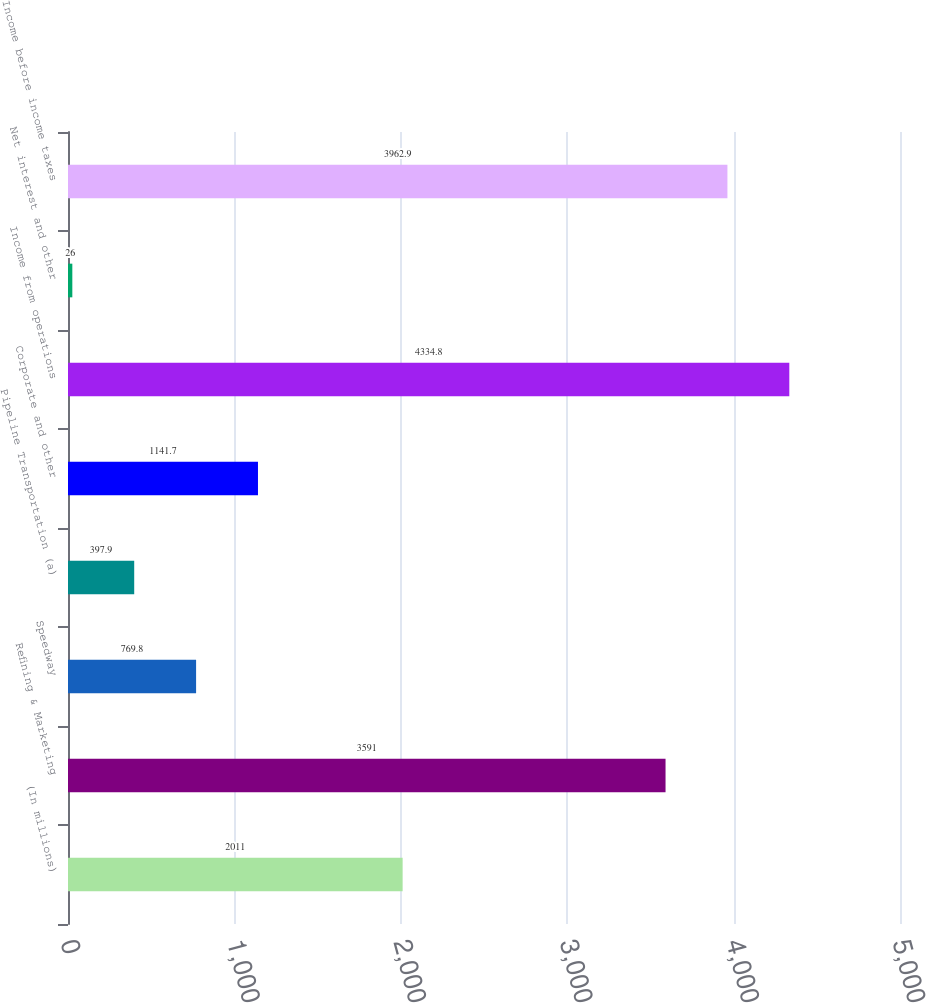<chart> <loc_0><loc_0><loc_500><loc_500><bar_chart><fcel>(In millions)<fcel>Refining & Marketing<fcel>Speedway<fcel>Pipeline Transportation (a)<fcel>Corporate and other<fcel>Income from operations<fcel>Net interest and other<fcel>Income before income taxes<nl><fcel>2011<fcel>3591<fcel>769.8<fcel>397.9<fcel>1141.7<fcel>4334.8<fcel>26<fcel>3962.9<nl></chart> 